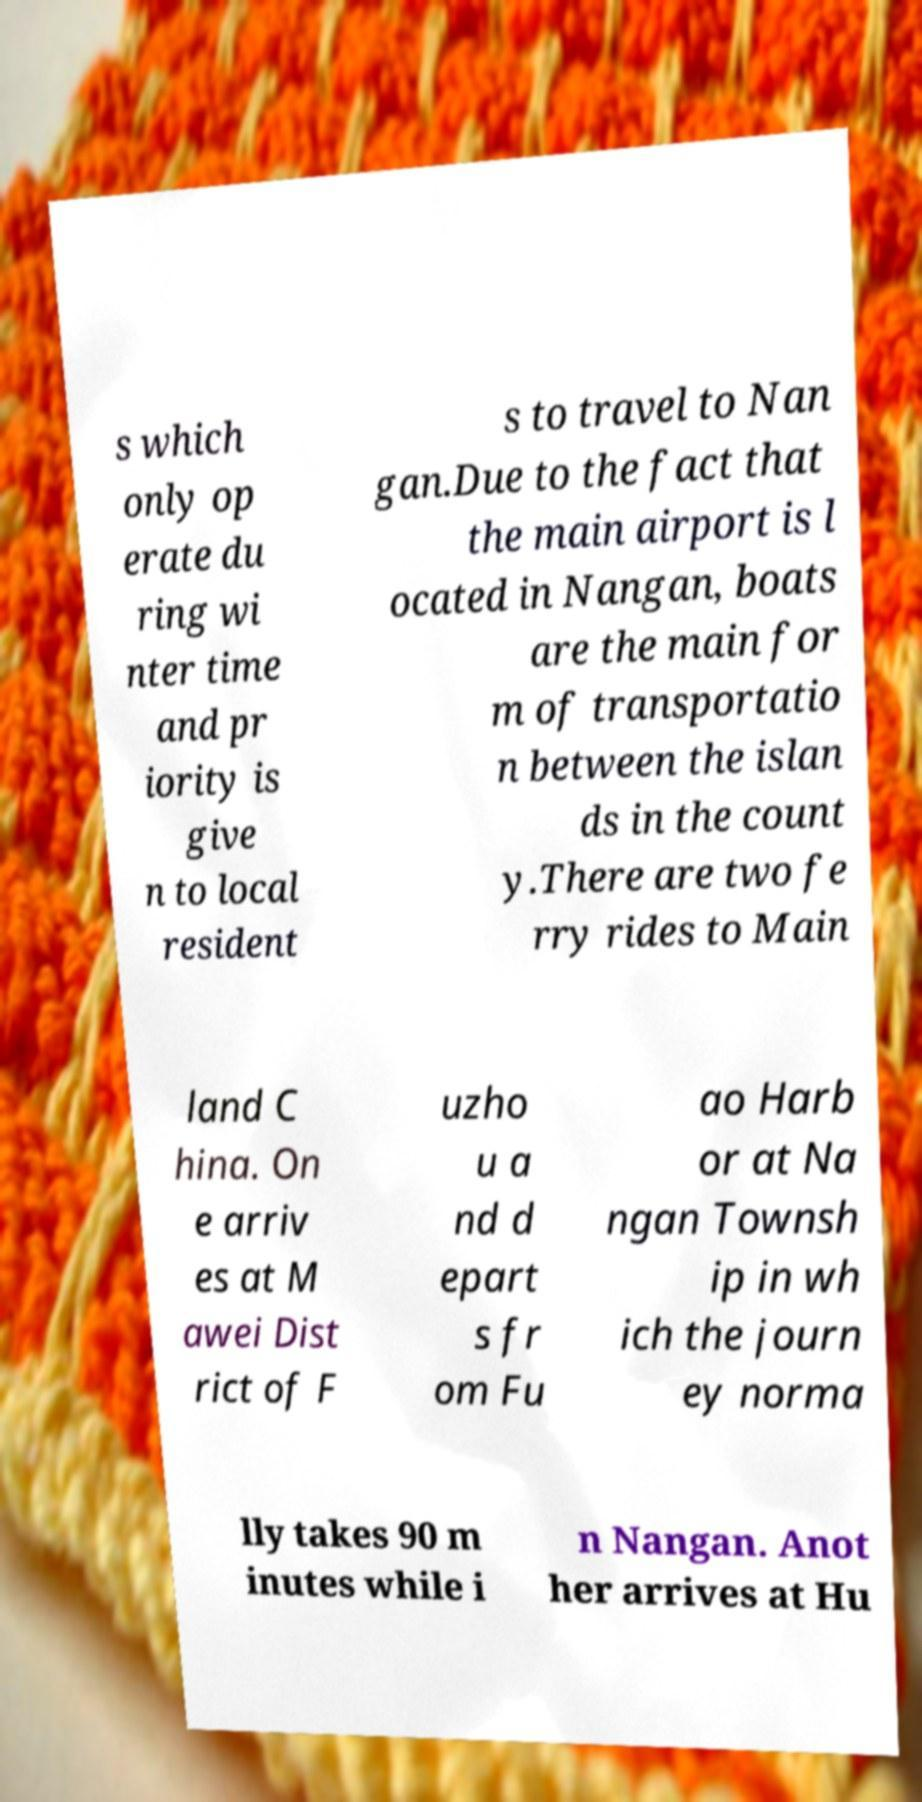Could you extract and type out the text from this image? s which only op erate du ring wi nter time and pr iority is give n to local resident s to travel to Nan gan.Due to the fact that the main airport is l ocated in Nangan, boats are the main for m of transportatio n between the islan ds in the count y.There are two fe rry rides to Main land C hina. On e arriv es at M awei Dist rict of F uzho u a nd d epart s fr om Fu ao Harb or at Na ngan Townsh ip in wh ich the journ ey norma lly takes 90 m inutes while i n Nangan. Anot her arrives at Hu 